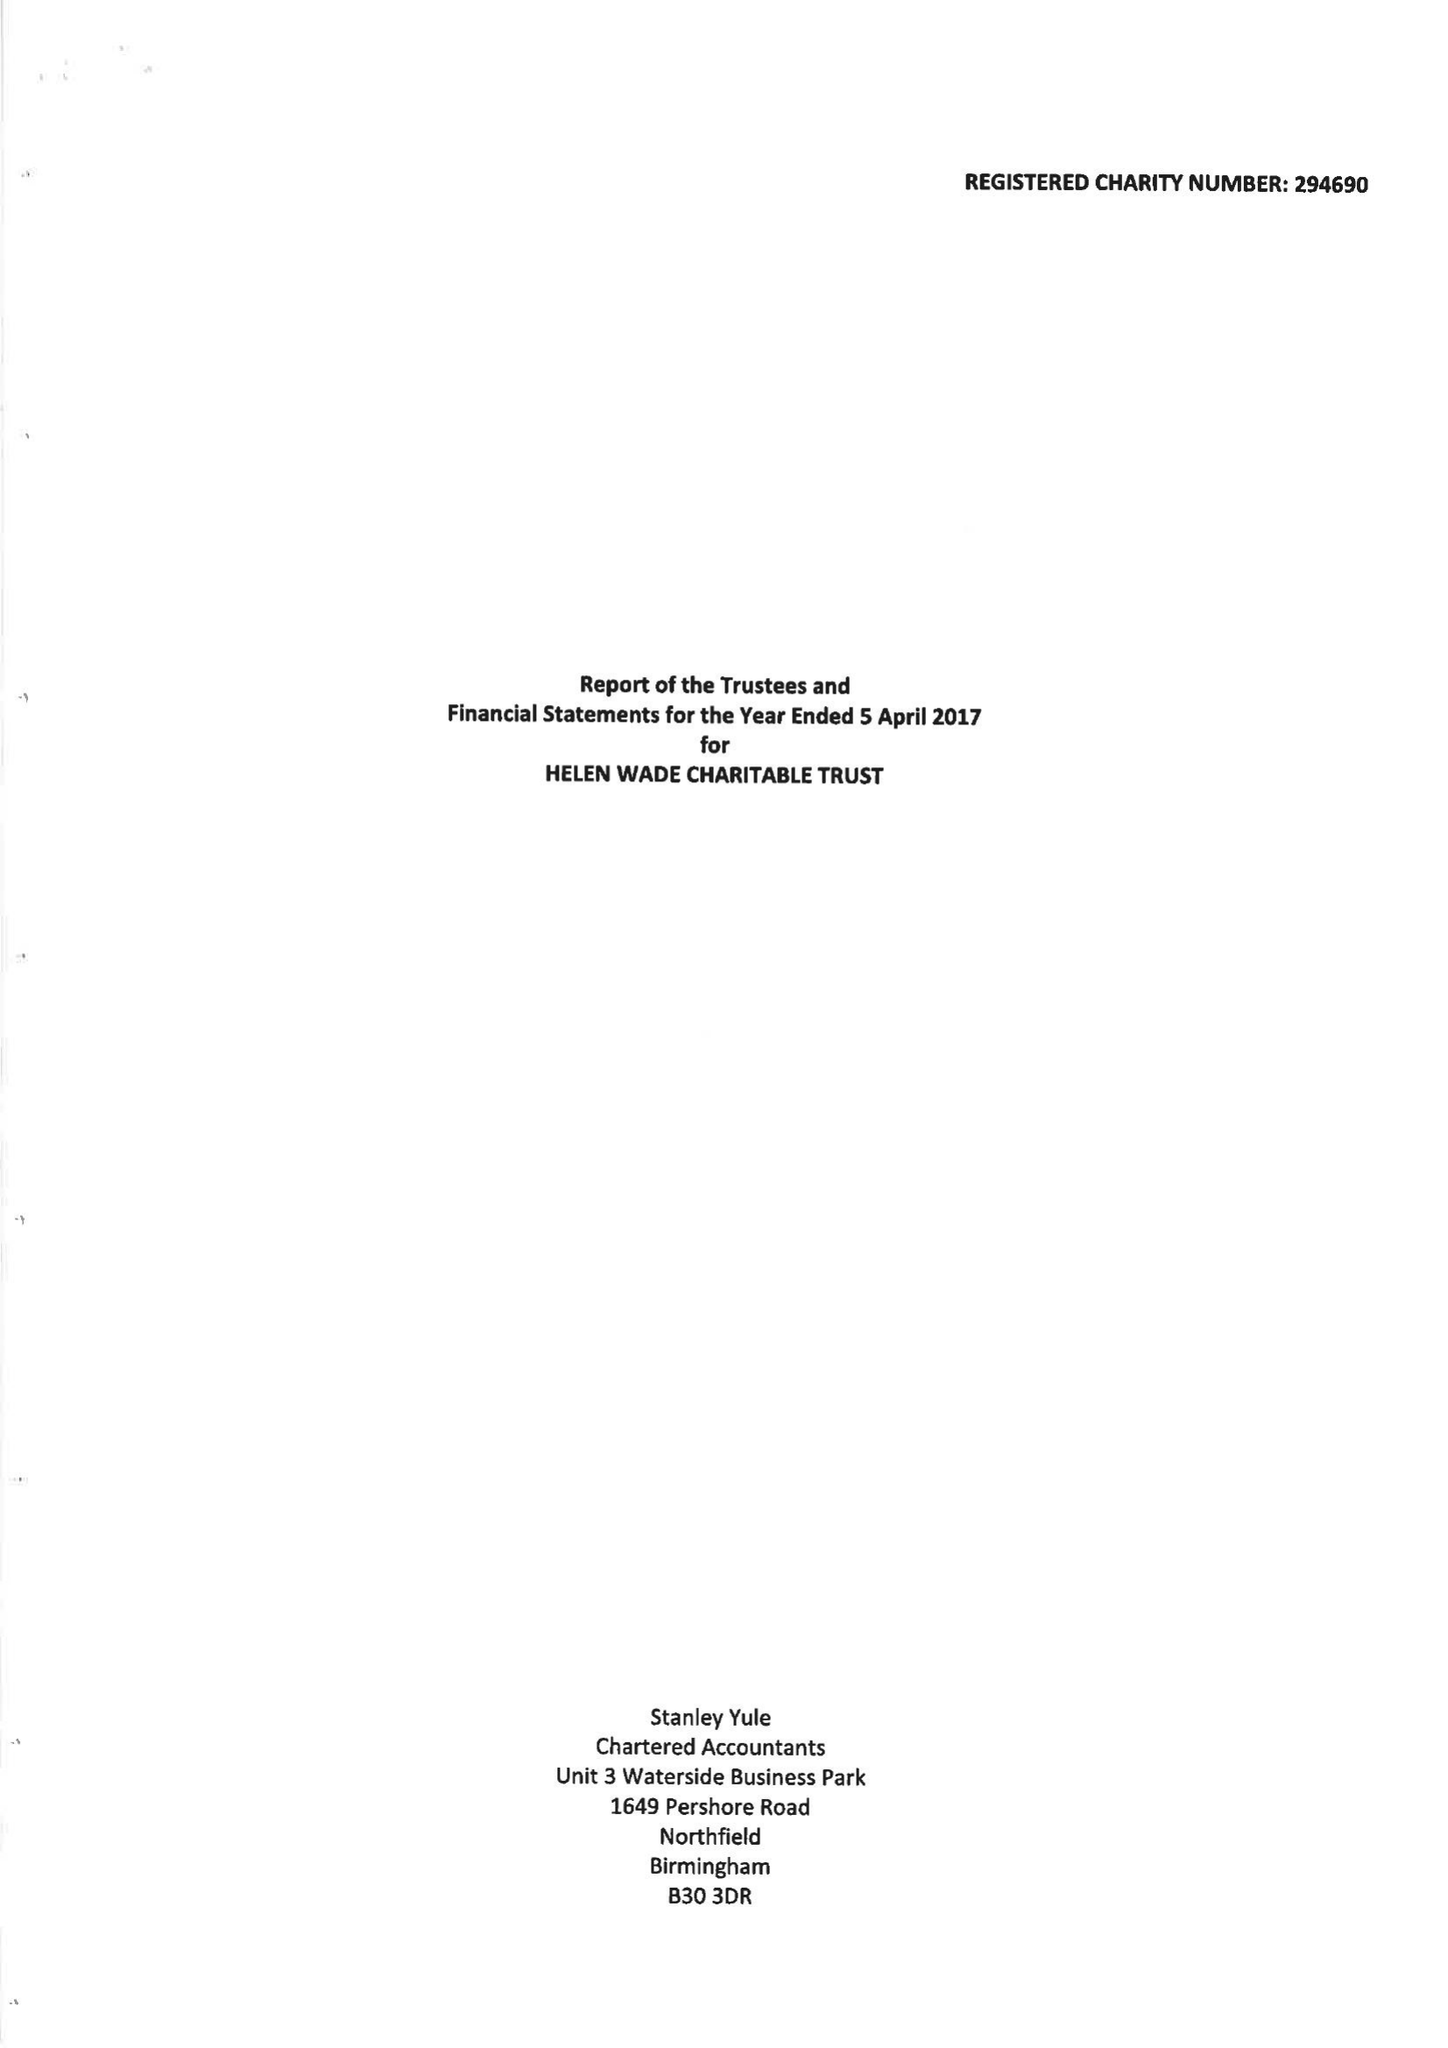What is the value for the report_date?
Answer the question using a single word or phrase. 2017-04-05 